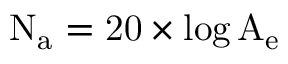Convert formula to latex. <formula><loc_0><loc_0><loc_500><loc_500>{ N _ { a } } = 2 0 \times \log \mathrm { { A _ { e } } }</formula> 